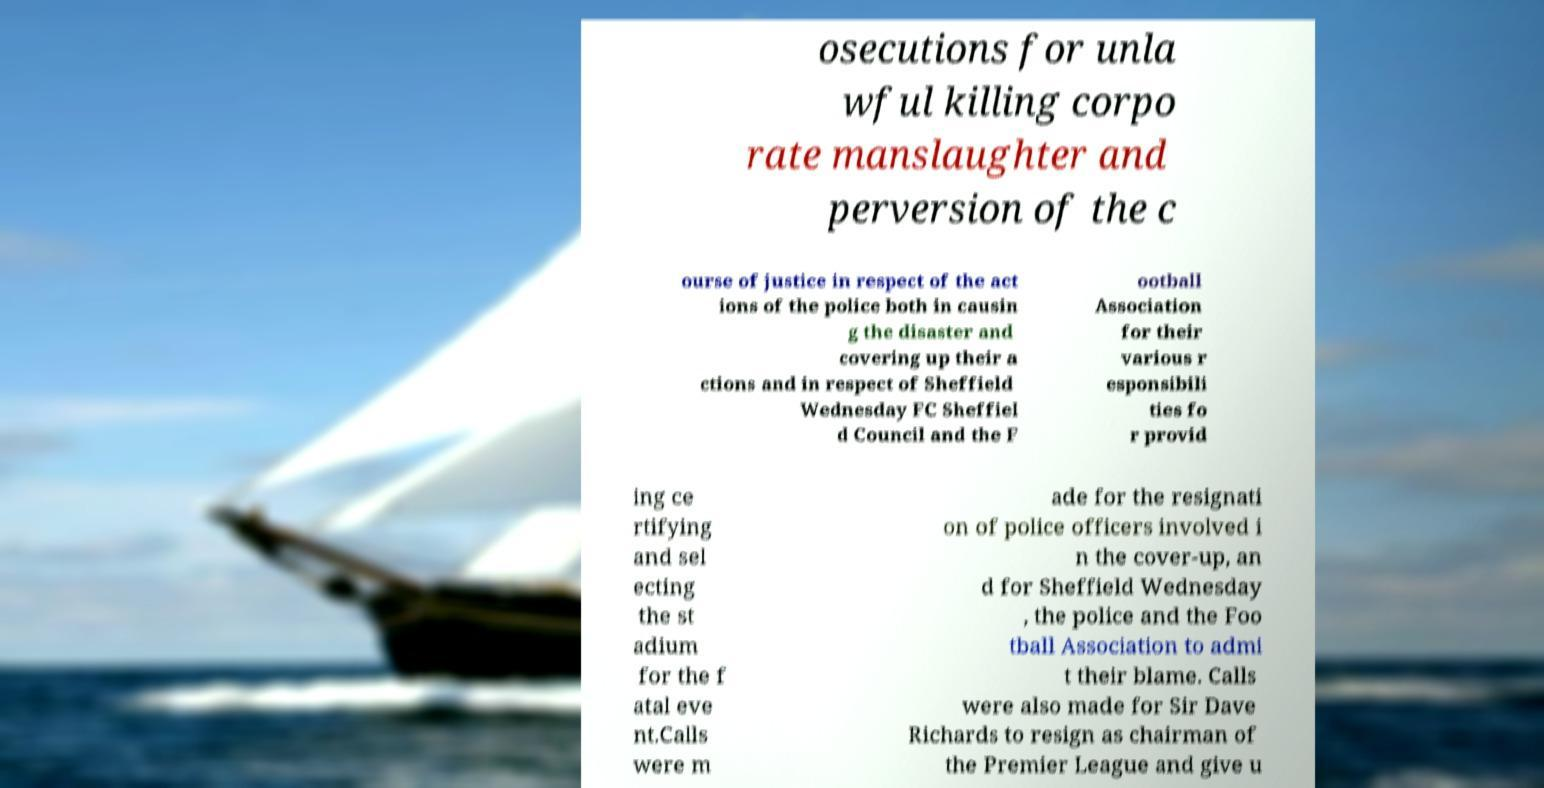Could you extract and type out the text from this image? osecutions for unla wful killing corpo rate manslaughter and perversion of the c ourse of justice in respect of the act ions of the police both in causin g the disaster and covering up their a ctions and in respect of Sheffield Wednesday FC Sheffiel d Council and the F ootball Association for their various r esponsibili ties fo r provid ing ce rtifying and sel ecting the st adium for the f atal eve nt.Calls were m ade for the resignati on of police officers involved i n the cover-up, an d for Sheffield Wednesday , the police and the Foo tball Association to admi t their blame. Calls were also made for Sir Dave Richards to resign as chairman of the Premier League and give u 